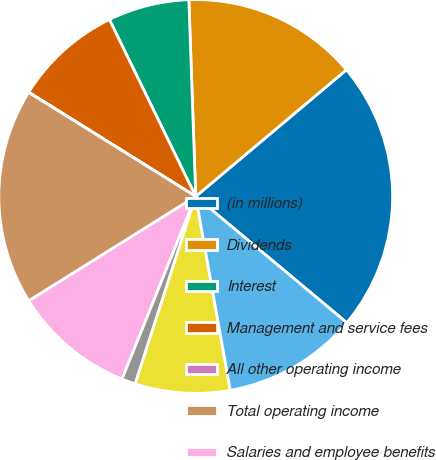Convert chart. <chart><loc_0><loc_0><loc_500><loc_500><pie_chart><fcel>(in millions)<fcel>Dividends<fcel>Interest<fcel>Management and service fees<fcel>All other operating income<fcel>Total operating income<fcel>Salaries and employee benefits<fcel>Interest expense<fcel>All other expenses<fcel>Total operating expense<nl><fcel>22.2%<fcel>14.43%<fcel>6.67%<fcel>8.89%<fcel>0.02%<fcel>17.76%<fcel>10.0%<fcel>1.13%<fcel>7.78%<fcel>11.11%<nl></chart> 